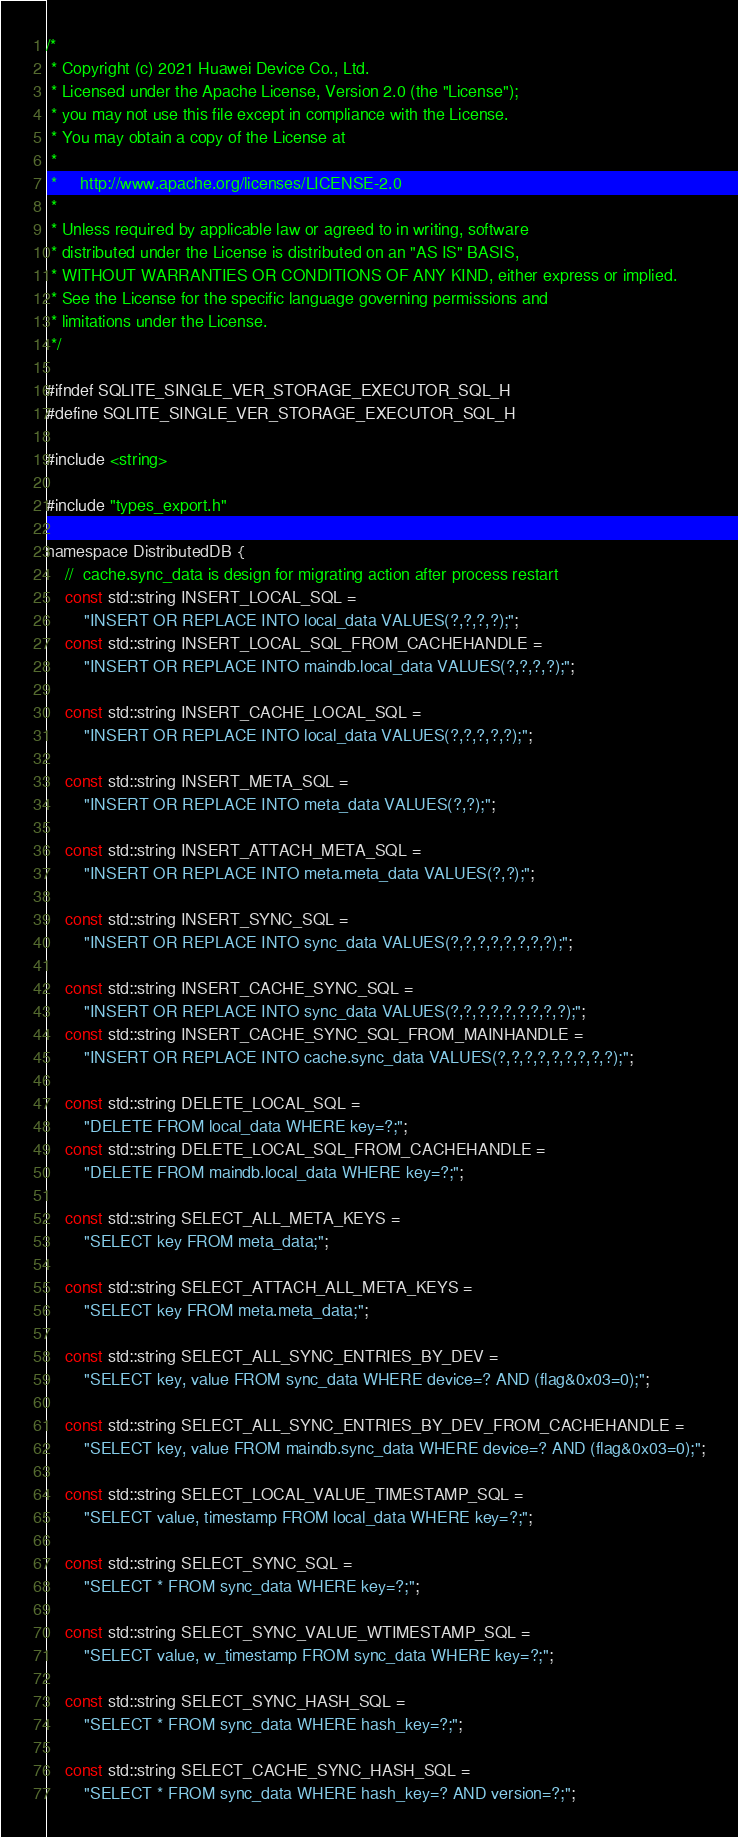Convert code to text. <code><loc_0><loc_0><loc_500><loc_500><_C_>/*
 * Copyright (c) 2021 Huawei Device Co., Ltd.
 * Licensed under the Apache License, Version 2.0 (the "License");
 * you may not use this file except in compliance with the License.
 * You may obtain a copy of the License at
 *
 *     http://www.apache.org/licenses/LICENSE-2.0
 *
 * Unless required by applicable law or agreed to in writing, software
 * distributed under the License is distributed on an "AS IS" BASIS,
 * WITHOUT WARRANTIES OR CONDITIONS OF ANY KIND, either express or implied.
 * See the License for the specific language governing permissions and
 * limitations under the License.
 */

#ifndef SQLITE_SINGLE_VER_STORAGE_EXECUTOR_SQL_H
#define SQLITE_SINGLE_VER_STORAGE_EXECUTOR_SQL_H

#include <string>

#include "types_export.h"

namespace DistributedDB {
    //  cache.sync_data is design for migrating action after process restart
    const std::string INSERT_LOCAL_SQL =
        "INSERT OR REPLACE INTO local_data VALUES(?,?,?,?);";
    const std::string INSERT_LOCAL_SQL_FROM_CACHEHANDLE =
        "INSERT OR REPLACE INTO maindb.local_data VALUES(?,?,?,?);";

    const std::string INSERT_CACHE_LOCAL_SQL =
        "INSERT OR REPLACE INTO local_data VALUES(?,?,?,?,?);";

    const std::string INSERT_META_SQL =
        "INSERT OR REPLACE INTO meta_data VALUES(?,?);";

    const std::string INSERT_ATTACH_META_SQL =
        "INSERT OR REPLACE INTO meta.meta_data VALUES(?,?);";

    const std::string INSERT_SYNC_SQL =
        "INSERT OR REPLACE INTO sync_data VALUES(?,?,?,?,?,?,?,?);";

    const std::string INSERT_CACHE_SYNC_SQL =
        "INSERT OR REPLACE INTO sync_data VALUES(?,?,?,?,?,?,?,?,?);";
    const std::string INSERT_CACHE_SYNC_SQL_FROM_MAINHANDLE =
        "INSERT OR REPLACE INTO cache.sync_data VALUES(?,?,?,?,?,?,?,?,?);";

    const std::string DELETE_LOCAL_SQL =
        "DELETE FROM local_data WHERE key=?;";
    const std::string DELETE_LOCAL_SQL_FROM_CACHEHANDLE =
        "DELETE FROM maindb.local_data WHERE key=?;";

    const std::string SELECT_ALL_META_KEYS =
        "SELECT key FROM meta_data;";

    const std::string SELECT_ATTACH_ALL_META_KEYS =
        "SELECT key FROM meta.meta_data;";

    const std::string SELECT_ALL_SYNC_ENTRIES_BY_DEV =
        "SELECT key, value FROM sync_data WHERE device=? AND (flag&0x03=0);";

    const std::string SELECT_ALL_SYNC_ENTRIES_BY_DEV_FROM_CACHEHANDLE =
        "SELECT key, value FROM maindb.sync_data WHERE device=? AND (flag&0x03=0);";

    const std::string SELECT_LOCAL_VALUE_TIMESTAMP_SQL =
        "SELECT value, timestamp FROM local_data WHERE key=?;";

    const std::string SELECT_SYNC_SQL =
        "SELECT * FROM sync_data WHERE key=?;";

    const std::string SELECT_SYNC_VALUE_WTIMESTAMP_SQL =
        "SELECT value, w_timestamp FROM sync_data WHERE key=?;";

    const std::string SELECT_SYNC_HASH_SQL =
        "SELECT * FROM sync_data WHERE hash_key=?;";

    const std::string SELECT_CACHE_SYNC_HASH_SQL =
        "SELECT * FROM sync_data WHERE hash_key=? AND version=?;";</code> 